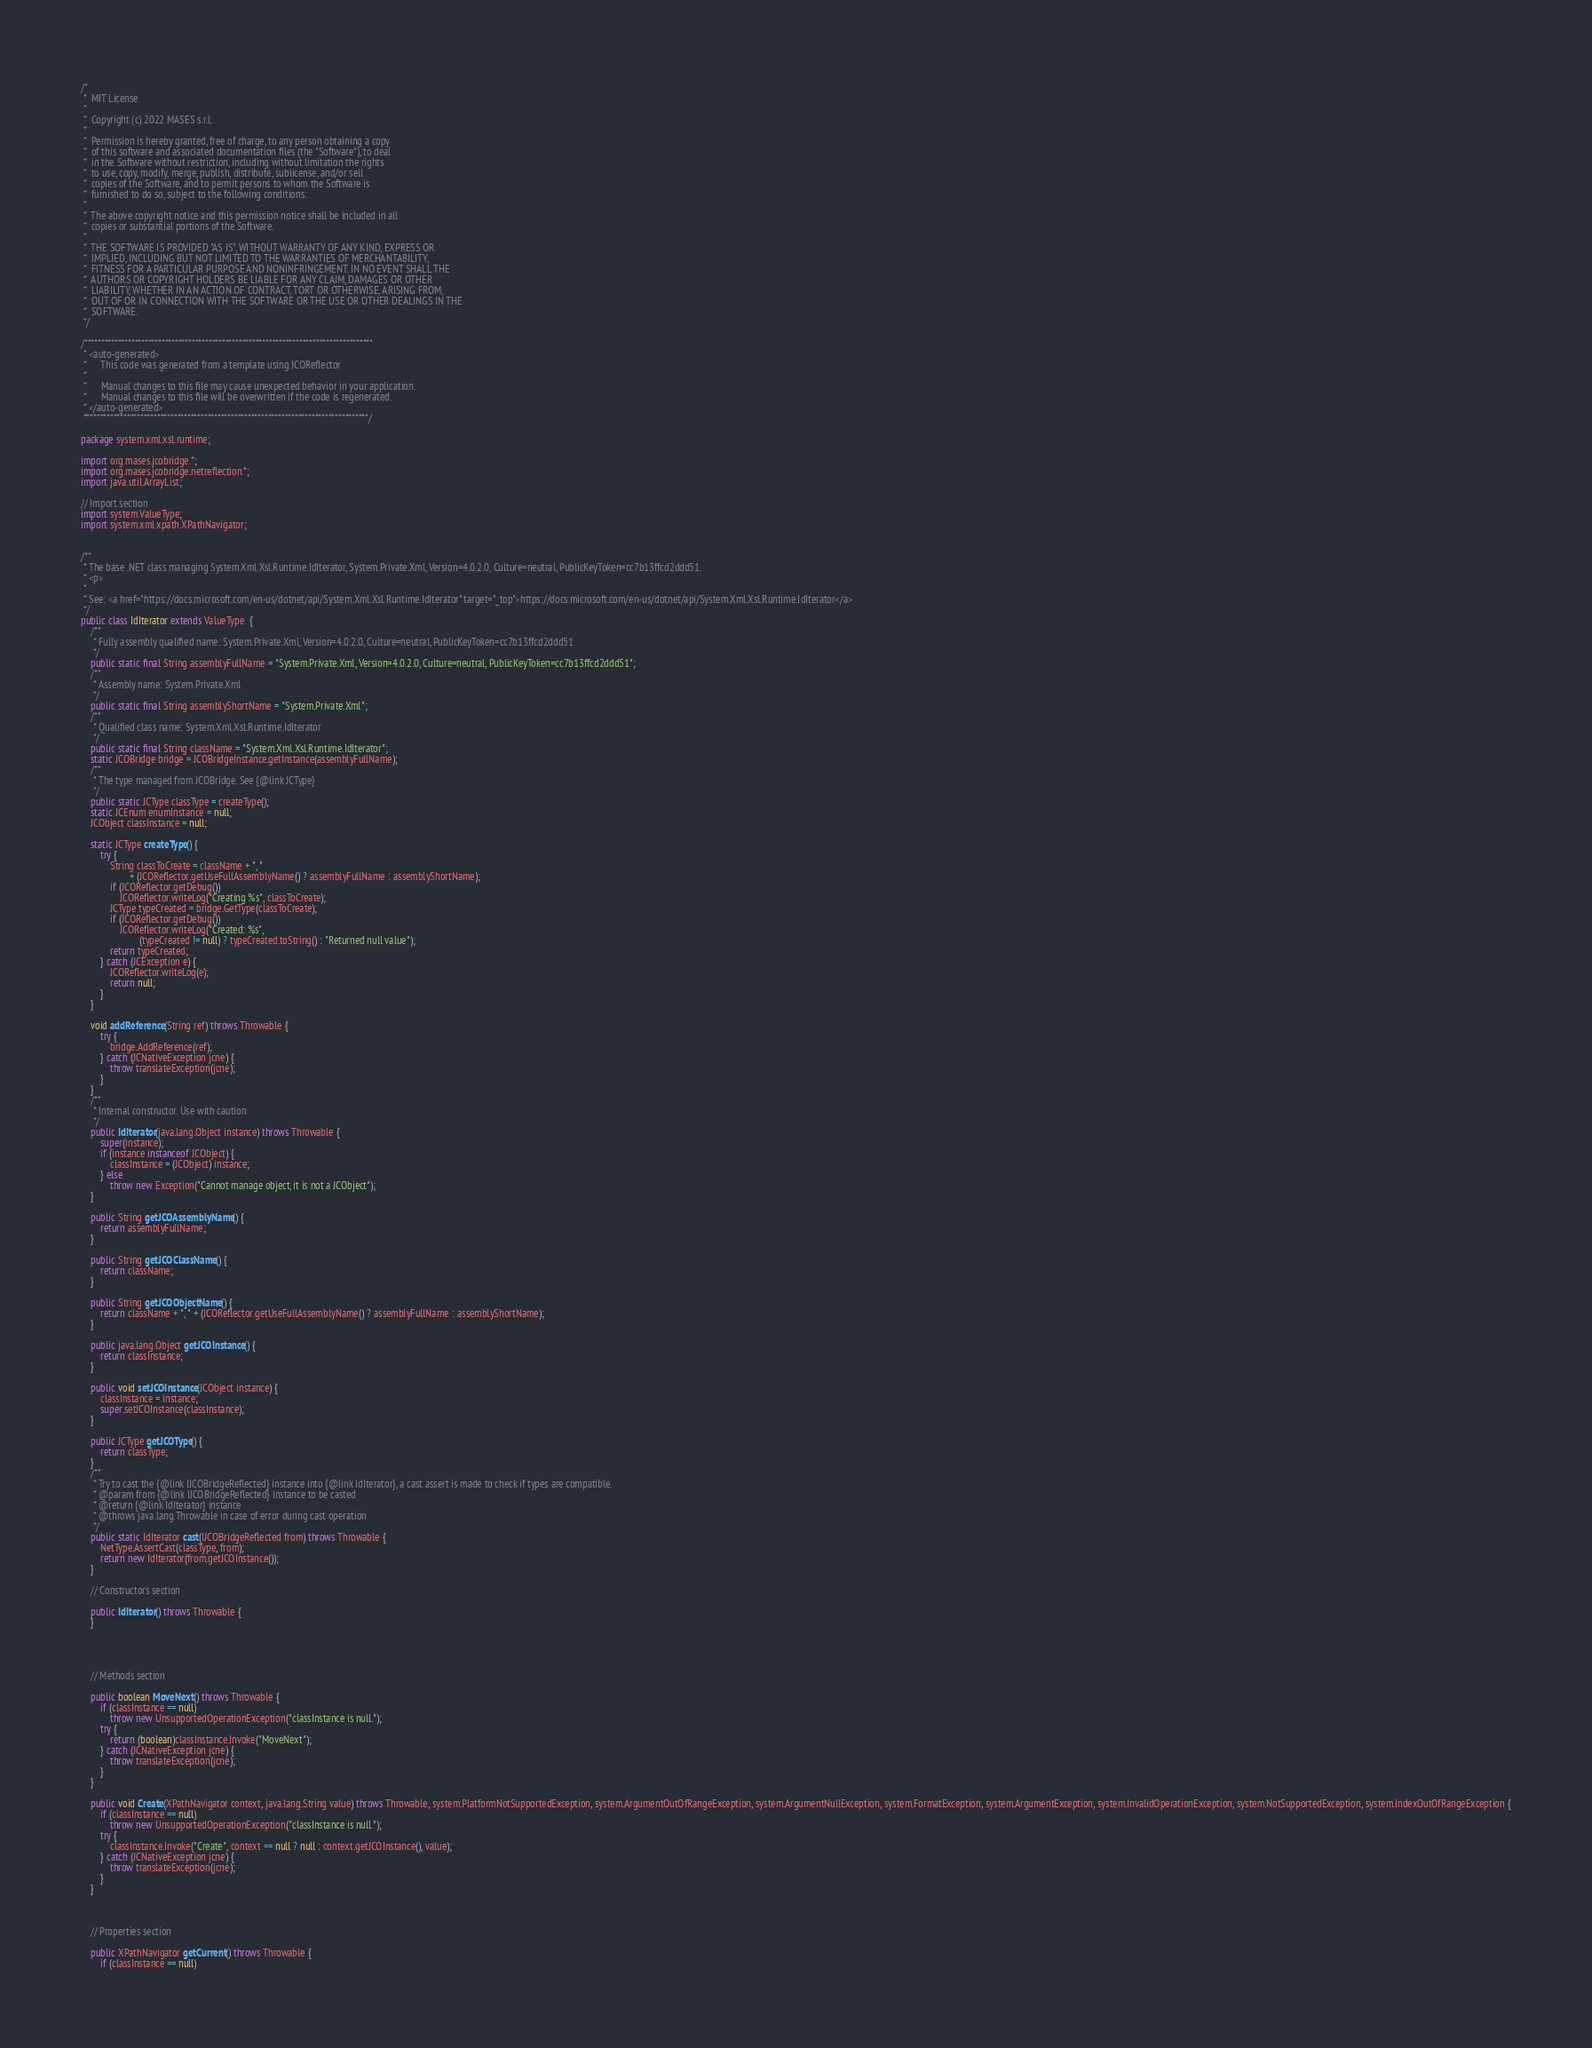<code> <loc_0><loc_0><loc_500><loc_500><_Java_>/*
 *  MIT License
 *
 *  Copyright (c) 2022 MASES s.r.l.
 *
 *  Permission is hereby granted, free of charge, to any person obtaining a copy
 *  of this software and associated documentation files (the "Software"), to deal
 *  in the Software without restriction, including without limitation the rights
 *  to use, copy, modify, merge, publish, distribute, sublicense, and/or sell
 *  copies of the Software, and to permit persons to whom the Software is
 *  furnished to do so, subject to the following conditions:
 *
 *  The above copyright notice and this permission notice shall be included in all
 *  copies or substantial portions of the Software.
 *
 *  THE SOFTWARE IS PROVIDED "AS IS", WITHOUT WARRANTY OF ANY KIND, EXPRESS OR
 *  IMPLIED, INCLUDING BUT NOT LIMITED TO THE WARRANTIES OF MERCHANTABILITY,
 *  FITNESS FOR A PARTICULAR PURPOSE AND NONINFRINGEMENT. IN NO EVENT SHALL THE
 *  AUTHORS OR COPYRIGHT HOLDERS BE LIABLE FOR ANY CLAIM, DAMAGES OR OTHER
 *  LIABILITY, WHETHER IN AN ACTION OF CONTRACT, TORT OR OTHERWISE, ARISING FROM,
 *  OUT OF OR IN CONNECTION WITH THE SOFTWARE OR THE USE OR OTHER DEALINGS IN THE
 *  SOFTWARE.
 */

/**************************************************************************************
 * <auto-generated>
 *      This code was generated from a template using JCOReflector
 * 
 *      Manual changes to this file may cause unexpected behavior in your application.
 *      Manual changes to this file will be overwritten if the code is regenerated.
 * </auto-generated>
 *************************************************************************************/

package system.xml.xsl.runtime;

import org.mases.jcobridge.*;
import org.mases.jcobridge.netreflection.*;
import java.util.ArrayList;

// Import section
import system.ValueType;
import system.xml.xpath.XPathNavigator;


/**
 * The base .NET class managing System.Xml.Xsl.Runtime.IdIterator, System.Private.Xml, Version=4.0.2.0, Culture=neutral, PublicKeyToken=cc7b13ffcd2ddd51.
 * <p>
 * 
 * See: <a href="https://docs.microsoft.com/en-us/dotnet/api/System.Xml.Xsl.Runtime.IdIterator" target="_top">https://docs.microsoft.com/en-us/dotnet/api/System.Xml.Xsl.Runtime.IdIterator</a>
 */
public class IdIterator extends ValueType  {
    /**
     * Fully assembly qualified name: System.Private.Xml, Version=4.0.2.0, Culture=neutral, PublicKeyToken=cc7b13ffcd2ddd51
     */
    public static final String assemblyFullName = "System.Private.Xml, Version=4.0.2.0, Culture=neutral, PublicKeyToken=cc7b13ffcd2ddd51";
    /**
     * Assembly name: System.Private.Xml
     */
    public static final String assemblyShortName = "System.Private.Xml";
    /**
     * Qualified class name: System.Xml.Xsl.Runtime.IdIterator
     */
    public static final String className = "System.Xml.Xsl.Runtime.IdIterator";
    static JCOBridge bridge = JCOBridgeInstance.getInstance(assemblyFullName);
    /**
     * The type managed from JCOBridge. See {@link JCType}
     */
    public static JCType classType = createType();
    static JCEnum enumInstance = null;
    JCObject classInstance = null;

    static JCType createType() {
        try {
            String classToCreate = className + ", "
                    + (JCOReflector.getUseFullAssemblyName() ? assemblyFullName : assemblyShortName);
            if (JCOReflector.getDebug())
                JCOReflector.writeLog("Creating %s", classToCreate);
            JCType typeCreated = bridge.GetType(classToCreate);
            if (JCOReflector.getDebug())
                JCOReflector.writeLog("Created: %s",
                        (typeCreated != null) ? typeCreated.toString() : "Returned null value");
            return typeCreated;
        } catch (JCException e) {
            JCOReflector.writeLog(e);
            return null;
        }
    }

    void addReference(String ref) throws Throwable {
        try {
            bridge.AddReference(ref);
        } catch (JCNativeException jcne) {
            throw translateException(jcne);
        }
    }
    /**
     * Internal constructor. Use with caution 
     */
    public IdIterator(java.lang.Object instance) throws Throwable {
        super(instance);
        if (instance instanceof JCObject) {
            classInstance = (JCObject) instance;
        } else
            throw new Exception("Cannot manage object, it is not a JCObject");
    }

    public String getJCOAssemblyName() {
        return assemblyFullName;
    }

    public String getJCOClassName() {
        return className;
    }

    public String getJCOObjectName() {
        return className + ", " + (JCOReflector.getUseFullAssemblyName() ? assemblyFullName : assemblyShortName);
    }

    public java.lang.Object getJCOInstance() {
        return classInstance;
    }

    public void setJCOInstance(JCObject instance) {
        classInstance = instance;
        super.setJCOInstance(classInstance);
    }

    public JCType getJCOType() {
        return classType;
    }
    /**
     * Try to cast the {@link IJCOBridgeReflected} instance into {@link IdIterator}, a cast assert is made to check if types are compatible.
     * @param from {@link IJCOBridgeReflected} instance to be casted
     * @return {@link IdIterator} instance
     * @throws java.lang.Throwable in case of error during cast operation
     */
    public static IdIterator cast(IJCOBridgeReflected from) throws Throwable {
        NetType.AssertCast(classType, from);
        return new IdIterator(from.getJCOInstance());
    }

    // Constructors section
    
    public IdIterator() throws Throwable {
    }



    
    // Methods section
    
    public boolean MoveNext() throws Throwable {
        if (classInstance == null)
            throw new UnsupportedOperationException("classInstance is null.");
        try {
            return (boolean)classInstance.Invoke("MoveNext");
        } catch (JCNativeException jcne) {
            throw translateException(jcne);
        }
    }

    public void Create(XPathNavigator context, java.lang.String value) throws Throwable, system.PlatformNotSupportedException, system.ArgumentOutOfRangeException, system.ArgumentNullException, system.FormatException, system.ArgumentException, system.InvalidOperationException, system.NotSupportedException, system.IndexOutOfRangeException {
        if (classInstance == null)
            throw new UnsupportedOperationException("classInstance is null.");
        try {
            classInstance.Invoke("Create", context == null ? null : context.getJCOInstance(), value);
        } catch (JCNativeException jcne) {
            throw translateException(jcne);
        }
    }


    
    // Properties section
    
    public XPathNavigator getCurrent() throws Throwable {
        if (classInstance == null)</code> 